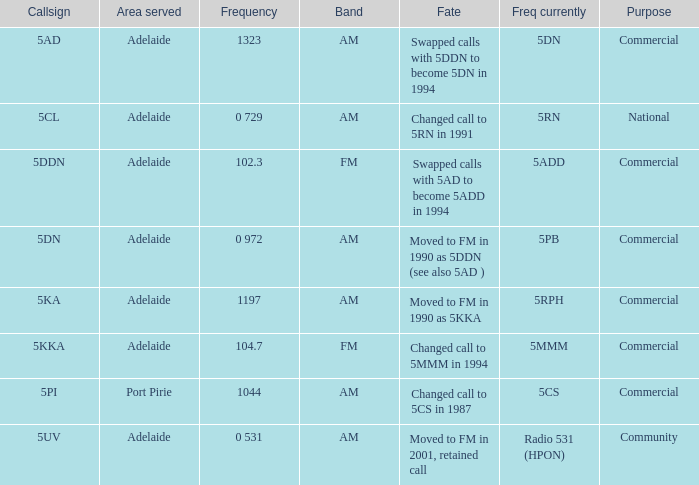What is the intention behind a 10 Commercial. Help me parse the entirety of this table. {'header': ['Callsign', 'Area served', 'Frequency', 'Band', 'Fate', 'Freq currently', 'Purpose'], 'rows': [['5AD', 'Adelaide', '1323', 'AM', 'Swapped calls with 5DDN to become 5DN in 1994', '5DN', 'Commercial'], ['5CL', 'Adelaide', '0 729', 'AM', 'Changed call to 5RN in 1991', '5RN', 'National'], ['5DDN', 'Adelaide', '102.3', 'FM', 'Swapped calls with 5AD to become 5ADD in 1994', '5ADD', 'Commercial'], ['5DN', 'Adelaide', '0 972', 'AM', 'Moved to FM in 1990 as 5DDN (see also 5AD )', '5PB', 'Commercial'], ['5KA', 'Adelaide', '1197', 'AM', 'Moved to FM in 1990 as 5KKA', '5RPH', 'Commercial'], ['5KKA', 'Adelaide', '104.7', 'FM', 'Changed call to 5MMM in 1994', '5MMM', 'Commercial'], ['5PI', 'Port Pirie', '1044', 'AM', 'Changed call to 5CS in 1987', '5CS', 'Commercial'], ['5UV', 'Adelaide', '0 531', 'AM', 'Moved to FM in 2001, retained call', 'Radio 531 (HPON)', 'Community']]} 